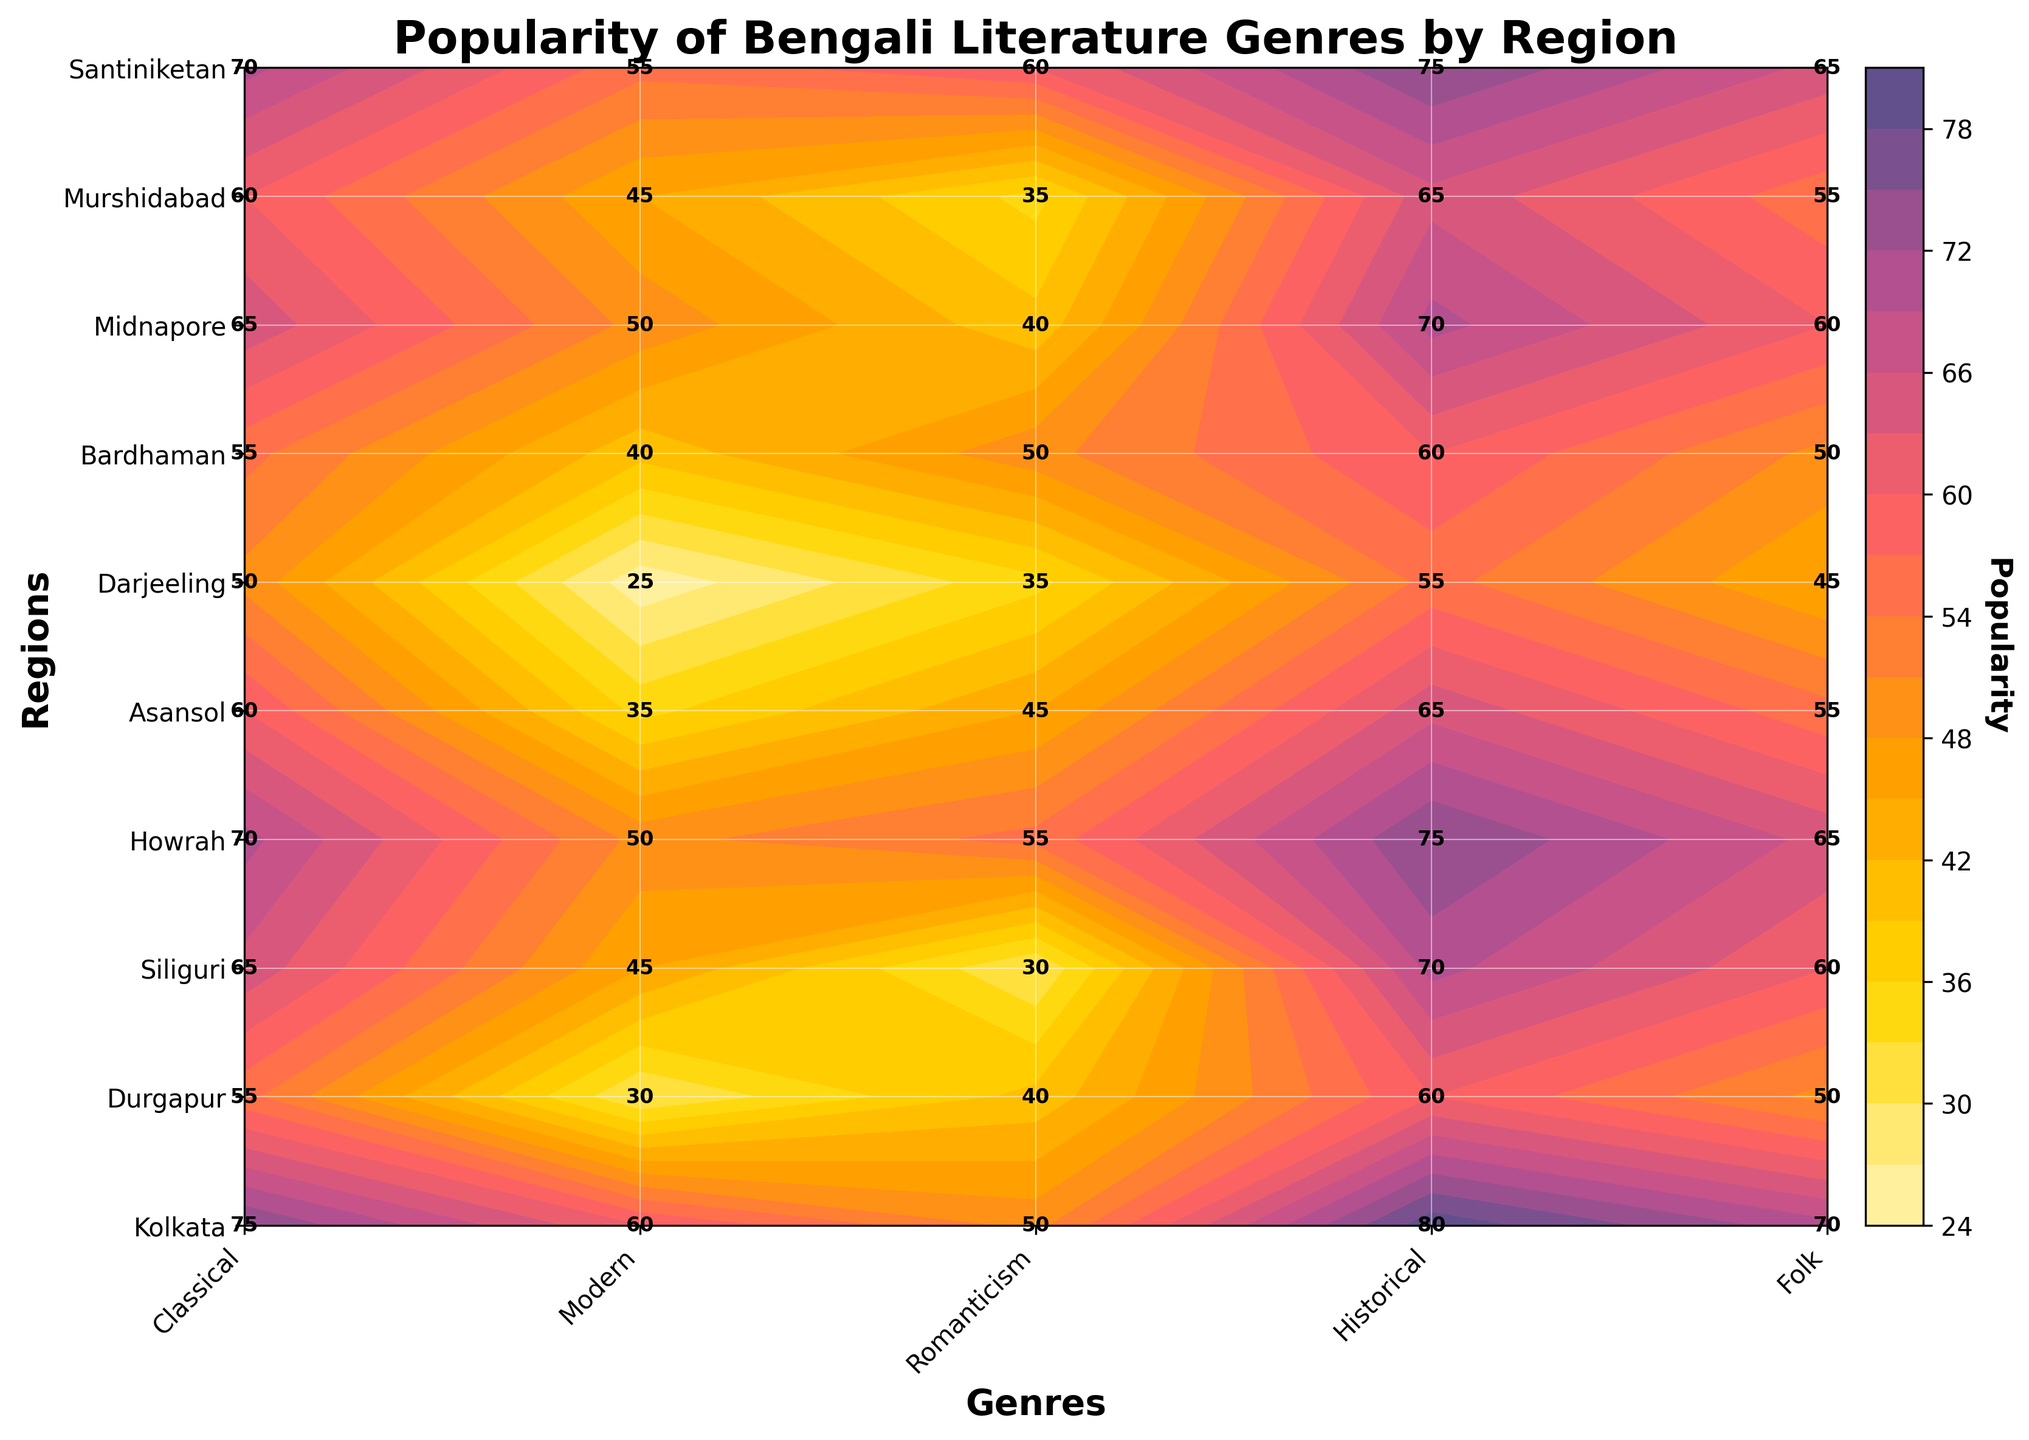What is the most popular genre in Kolkata? In the plot, look for the highest value in the row corresponding to Kolkata.
Answer: Historical Which region has the lowest popularity for the Modern genre? Find the row associated with the Modern genre and identify the region with the smallest value.
Answer: Darjeeling How does the Folk genre’s popularity compare between Midnapore and Siliguri? Look at the values for the Folk genre in the rows for Midnapore and Siliguri, then compare them.
Answer: Equal What is the average popularity of the Romanticism genre across all regions? Sum up all values in the column for Romanticism and divide by the number of regions (10).
Answer: 45 Which region has the greatest difference in popularity between the Classical and Modern genres? For each region, calculate the difference between the Classical and Modern values and identify the region with the largest difference.
Answer: Kolkata What is the title of the plot? The title is displayed at the top of the plot.
Answer: Popularity of Bengali Literature Genres by Region What is the color associated with the highest popularity values? Refer to the color gradient on the color bar that correlates with the highest values.
Answer: Dark blue Which two genres have the closest popularity values in Howrah? Compare the values within the row for Howrah and identify the genres with the smallest difference in their popularity.
Answer: Classical and Folk How many genres are displayed in the plot? Count the number of columns representing different genres.
Answer: 5 What is the total popularity score for Darjeeling across all genres? Sum up all values in the row for Darjeeling.
Answer: 210 